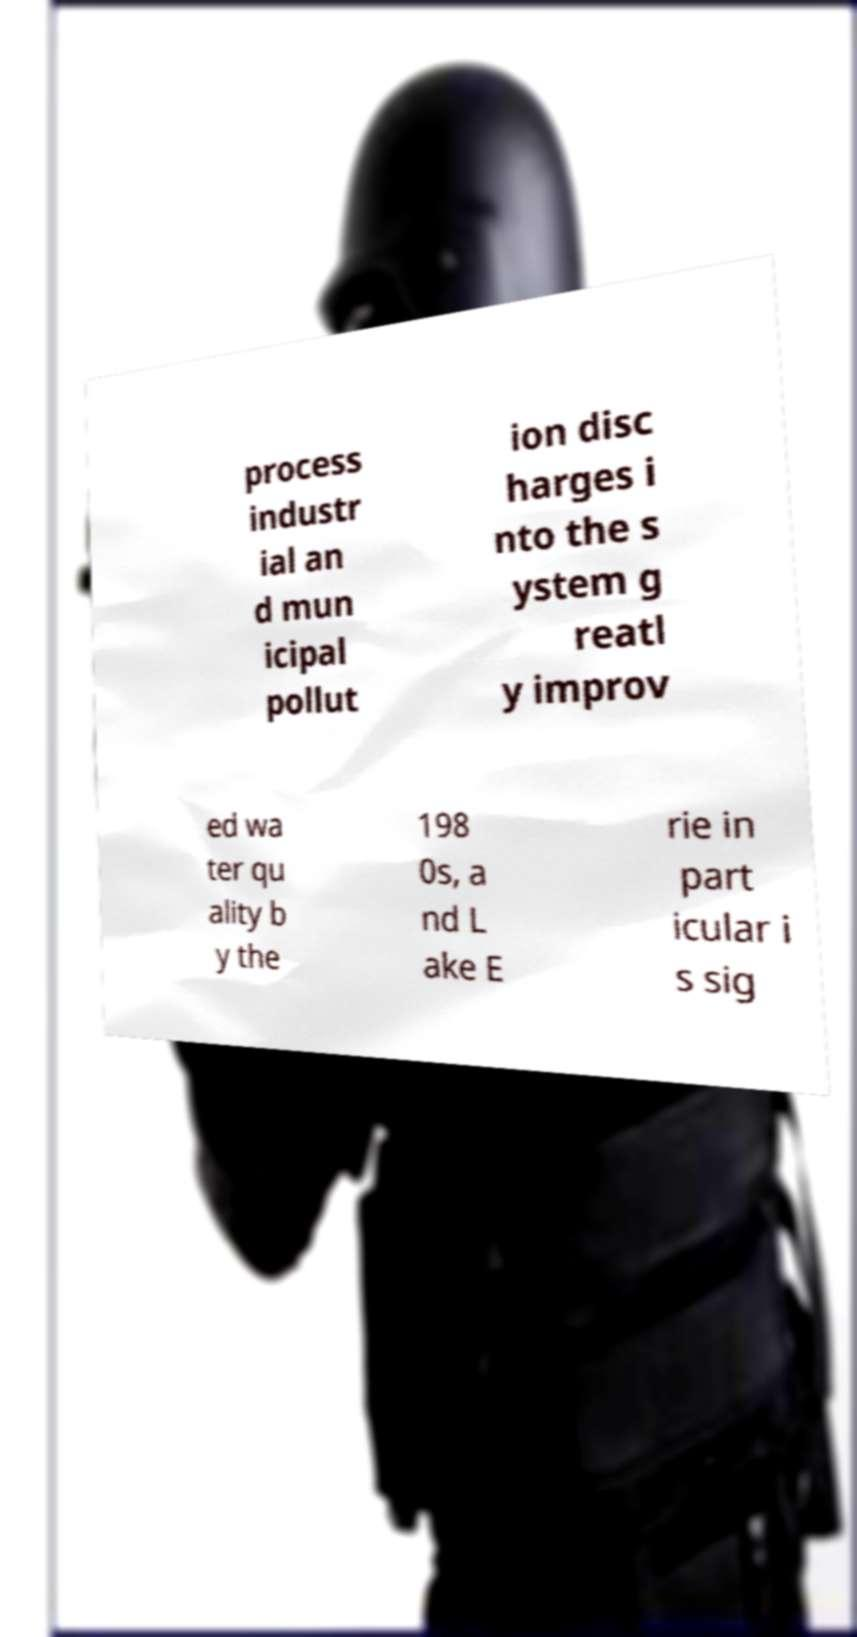I need the written content from this picture converted into text. Can you do that? process industr ial an d mun icipal pollut ion disc harges i nto the s ystem g reatl y improv ed wa ter qu ality b y the 198 0s, a nd L ake E rie in part icular i s sig 